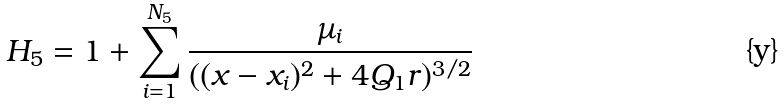<formula> <loc_0><loc_0><loc_500><loc_500>H _ { 5 } = 1 + \sum _ { i = 1 } ^ { N _ { 5 } } \frac { \mu _ { i } } { ( ( x - x _ { i } ) ^ { 2 } + 4 Q _ { 1 } r ) ^ { 3 / 2 } }</formula> 